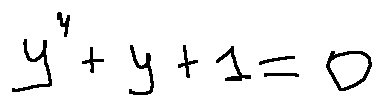Convert formula to latex. <formula><loc_0><loc_0><loc_500><loc_500>y ^ { 4 } + y + 1 = 0</formula> 